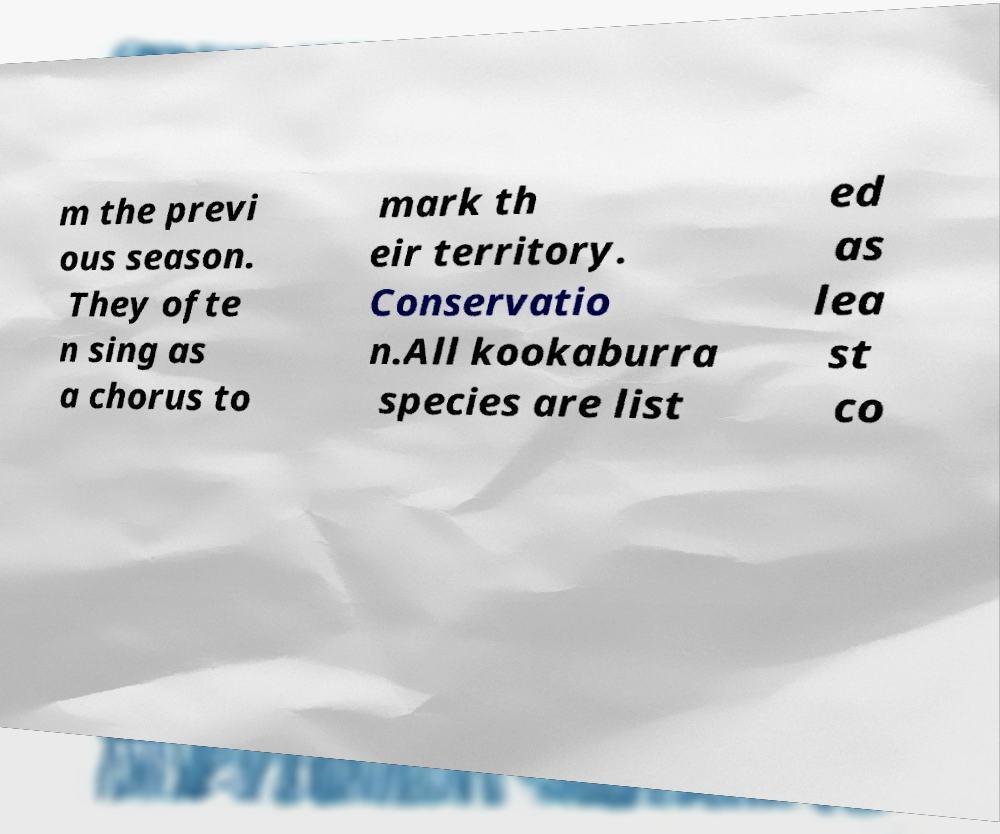Can you accurately transcribe the text from the provided image for me? m the previ ous season. They ofte n sing as a chorus to mark th eir territory. Conservatio n.All kookaburra species are list ed as lea st co 